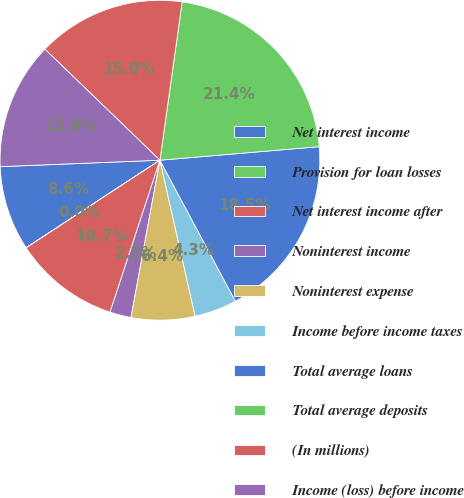<chart> <loc_0><loc_0><loc_500><loc_500><pie_chart><fcel>Net interest income<fcel>Provision for loan losses<fcel>Net interest income after<fcel>Noninterest income<fcel>Noninterest expense<fcel>Income before income taxes<fcel>Total average loans<fcel>Total average deposits<fcel>(In millions)<fcel>Income (loss) before income<nl><fcel>8.58%<fcel>0.01%<fcel>10.72%<fcel>2.15%<fcel>6.43%<fcel>4.29%<fcel>18.53%<fcel>21.43%<fcel>15.0%<fcel>12.86%<nl></chart> 